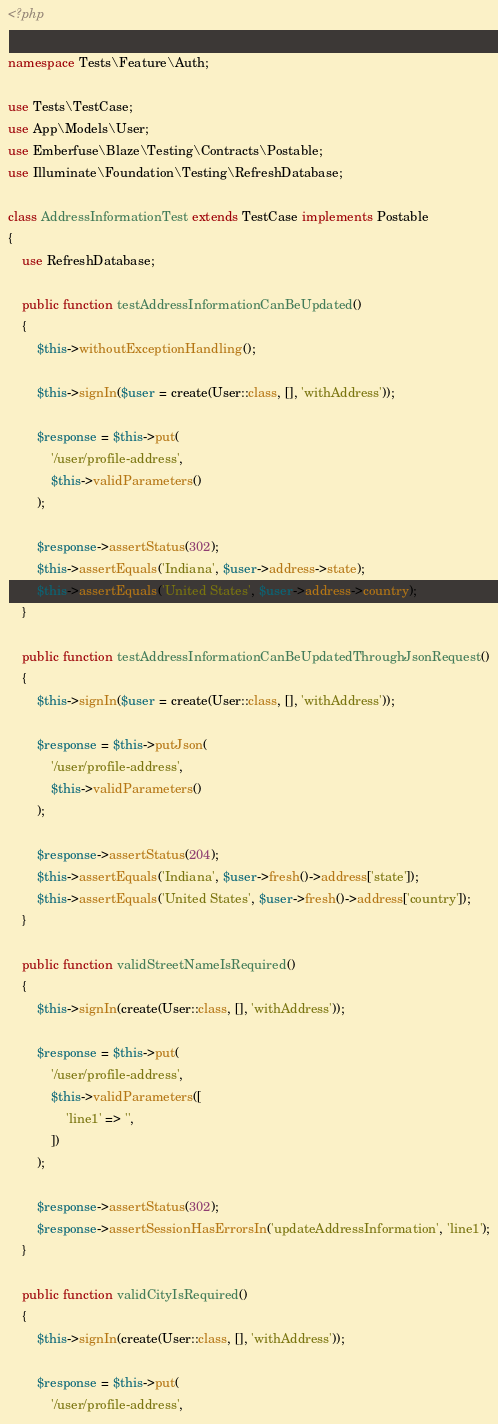<code> <loc_0><loc_0><loc_500><loc_500><_PHP_><?php

namespace Tests\Feature\Auth;

use Tests\TestCase;
use App\Models\User;
use Emberfuse\Blaze\Testing\Contracts\Postable;
use Illuminate\Foundation\Testing\RefreshDatabase;

class AddressInformationTest extends TestCase implements Postable
{
    use RefreshDatabase;

    public function testAddressInformationCanBeUpdated()
    {
        $this->withoutExceptionHandling();

        $this->signIn($user = create(User::class, [], 'withAddress'));

        $response = $this->put(
            '/user/profile-address',
            $this->validParameters()
        );

        $response->assertStatus(302);
        $this->assertEquals('Indiana', $user->address->state);
        $this->assertEquals('United States', $user->address->country);
    }

    public function testAddressInformationCanBeUpdatedThroughJsonRequest()
    {
        $this->signIn($user = create(User::class, [], 'withAddress'));

        $response = $this->putJson(
            '/user/profile-address',
            $this->validParameters()
        );

        $response->assertStatus(204);
        $this->assertEquals('Indiana', $user->fresh()->address['state']);
        $this->assertEquals('United States', $user->fresh()->address['country']);
    }

    public function validStreetNameIsRequired()
    {
        $this->signIn(create(User::class, [], 'withAddress'));

        $response = $this->put(
            '/user/profile-address',
            $this->validParameters([
                'line1' => '',
            ])
        );

        $response->assertStatus(302);
        $response->assertSessionHasErrorsIn('updateAddressInformation', 'line1');
    }

    public function validCityIsRequired()
    {
        $this->signIn(create(User::class, [], 'withAddress'));

        $response = $this->put(
            '/user/profile-address',</code> 